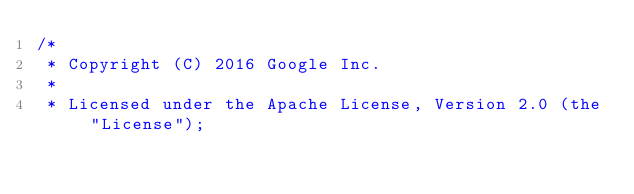<code> <loc_0><loc_0><loc_500><loc_500><_Java_>/*
 * Copyright (C) 2016 Google Inc.
 *
 * Licensed under the Apache License, Version 2.0 (the "License");</code> 